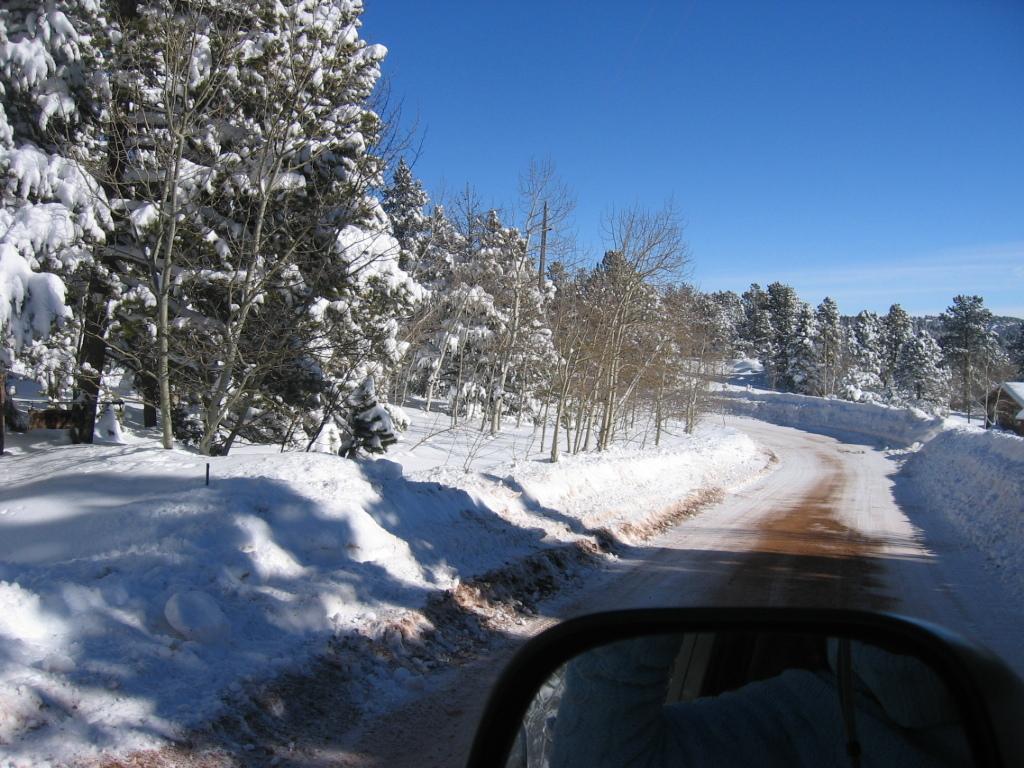Describe this image in one or two sentences. In this image in the center there is road. In the front there is a mirror in which the reflection of the person is visible. On the left side there are trees. In the background there are trees. On the right side there is cottage, on the roof of the cottage there is snow. 